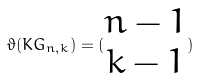Convert formula to latex. <formula><loc_0><loc_0><loc_500><loc_500>\vartheta ( K G _ { n , k } ) = ( \begin{matrix} n - 1 \\ k - 1 \end{matrix} )</formula> 